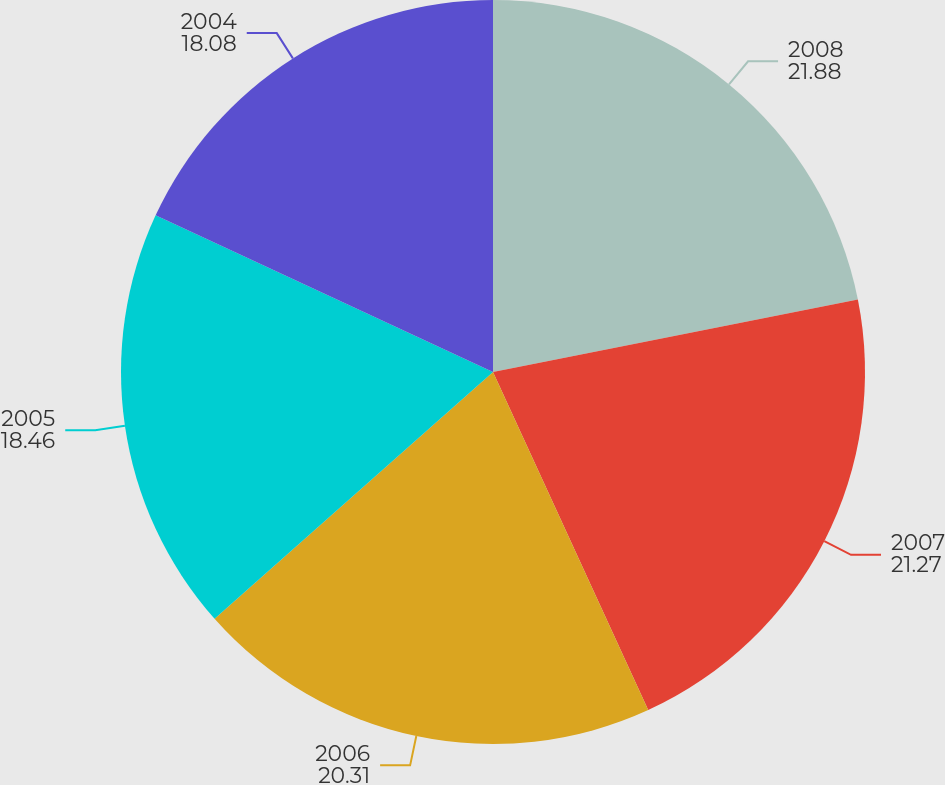<chart> <loc_0><loc_0><loc_500><loc_500><pie_chart><fcel>2008<fcel>2007<fcel>2006<fcel>2005<fcel>2004<nl><fcel>21.88%<fcel>21.27%<fcel>20.31%<fcel>18.46%<fcel>18.08%<nl></chart> 